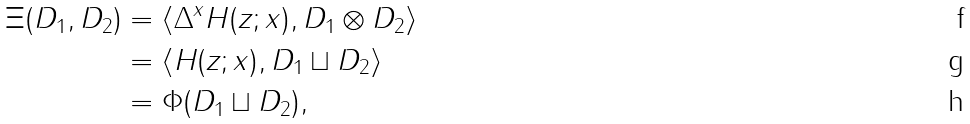<formula> <loc_0><loc_0><loc_500><loc_500>\Xi ( D _ { 1 } , D _ { 2 } ) & = \langle \Delta ^ { x } H ( z ; x ) , D _ { 1 } \otimes D _ { 2 } \rangle \\ & = \langle H ( z ; x ) , D _ { 1 } \sqcup D _ { 2 } \rangle \\ & = \Phi ( D _ { 1 } \sqcup D _ { 2 } ) ,</formula> 